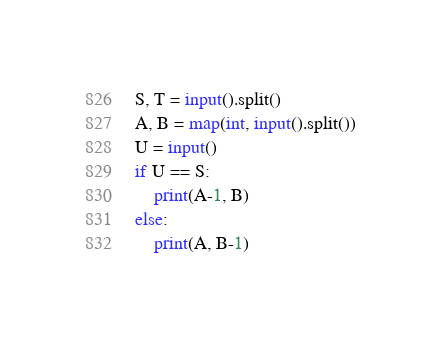<code> <loc_0><loc_0><loc_500><loc_500><_Python_>S, T = input().split()
A, B = map(int, input().split())
U = input()
if U == S:
    print(A-1, B)
else:
    print(A, B-1)</code> 